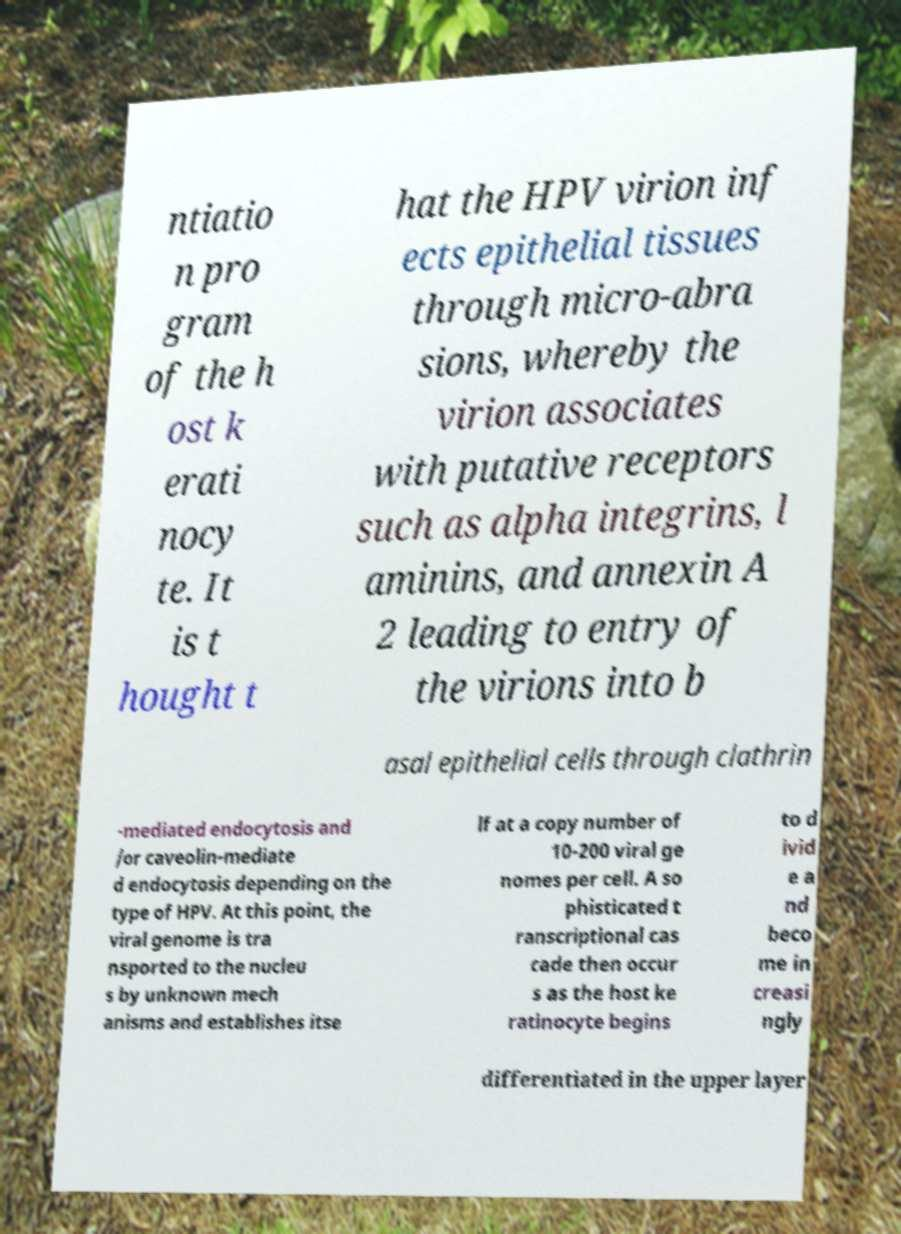Can you accurately transcribe the text from the provided image for me? ntiatio n pro gram of the h ost k erati nocy te. It is t hought t hat the HPV virion inf ects epithelial tissues through micro-abra sions, whereby the virion associates with putative receptors such as alpha integrins, l aminins, and annexin A 2 leading to entry of the virions into b asal epithelial cells through clathrin -mediated endocytosis and /or caveolin-mediate d endocytosis depending on the type of HPV. At this point, the viral genome is tra nsported to the nucleu s by unknown mech anisms and establishes itse lf at a copy number of 10-200 viral ge nomes per cell. A so phisticated t ranscriptional cas cade then occur s as the host ke ratinocyte begins to d ivid e a nd beco me in creasi ngly differentiated in the upper layer 